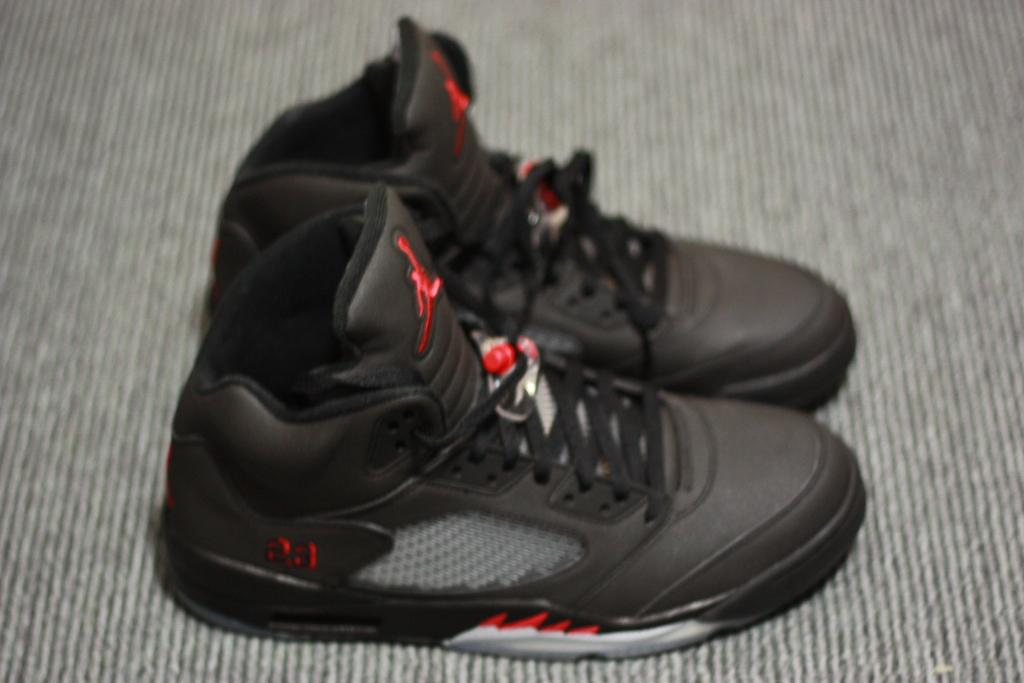What objects are in the image? There are shoes in the image. Where are the shoes located? The shoes are placed on the ground. What type of laborer is depicted working with a net in the image? There is no laborer or net present in the image; it only features shoes placed on the ground. 